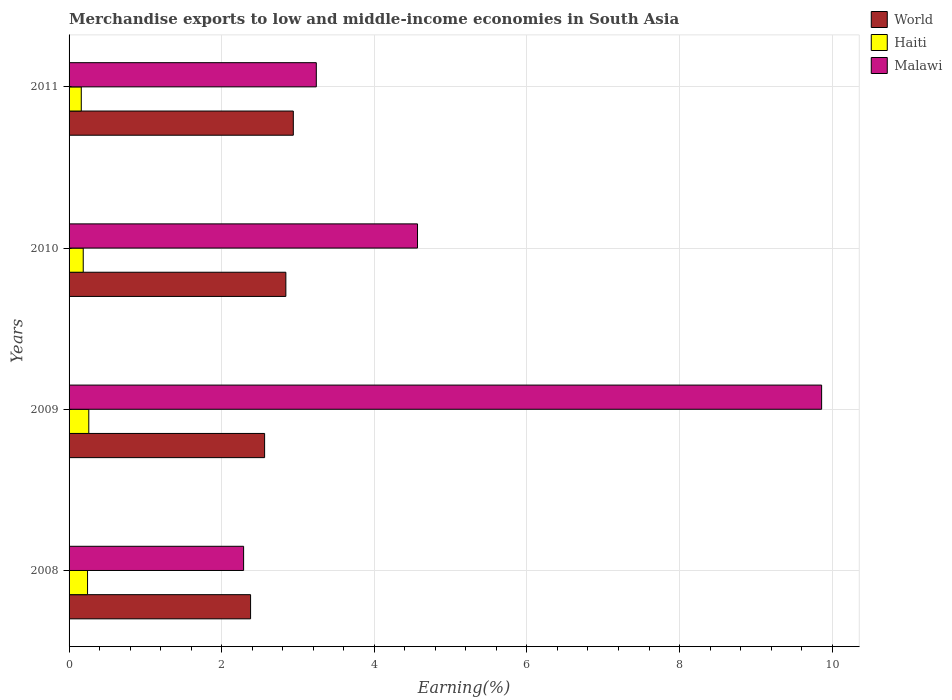How many groups of bars are there?
Offer a very short reply. 4. Are the number of bars per tick equal to the number of legend labels?
Keep it short and to the point. Yes. Are the number of bars on each tick of the Y-axis equal?
Your answer should be compact. Yes. How many bars are there on the 3rd tick from the top?
Offer a very short reply. 3. How many bars are there on the 2nd tick from the bottom?
Keep it short and to the point. 3. What is the label of the 2nd group of bars from the top?
Offer a very short reply. 2010. In how many cases, is the number of bars for a given year not equal to the number of legend labels?
Give a very brief answer. 0. What is the percentage of amount earned from merchandise exports in Haiti in 2008?
Offer a very short reply. 0.24. Across all years, what is the maximum percentage of amount earned from merchandise exports in Malawi?
Make the answer very short. 9.86. Across all years, what is the minimum percentage of amount earned from merchandise exports in World?
Ensure brevity in your answer.  2.38. In which year was the percentage of amount earned from merchandise exports in World maximum?
Your answer should be compact. 2011. What is the total percentage of amount earned from merchandise exports in Haiti in the graph?
Offer a terse response. 0.85. What is the difference between the percentage of amount earned from merchandise exports in World in 2010 and that in 2011?
Offer a very short reply. -0.1. What is the difference between the percentage of amount earned from merchandise exports in World in 2010 and the percentage of amount earned from merchandise exports in Haiti in 2008?
Make the answer very short. 2.6. What is the average percentage of amount earned from merchandise exports in World per year?
Keep it short and to the point. 2.68. In the year 2009, what is the difference between the percentage of amount earned from merchandise exports in Malawi and percentage of amount earned from merchandise exports in World?
Ensure brevity in your answer.  7.3. In how many years, is the percentage of amount earned from merchandise exports in Malawi greater than 3.2 %?
Your answer should be very brief. 3. What is the ratio of the percentage of amount earned from merchandise exports in Haiti in 2008 to that in 2010?
Your answer should be very brief. 1.3. Is the percentage of amount earned from merchandise exports in World in 2008 less than that in 2010?
Make the answer very short. Yes. What is the difference between the highest and the second highest percentage of amount earned from merchandise exports in World?
Your response must be concise. 0.1. What is the difference between the highest and the lowest percentage of amount earned from merchandise exports in World?
Give a very brief answer. 0.56. What does the 2nd bar from the top in 2011 represents?
Make the answer very short. Haiti. What does the 1st bar from the bottom in 2009 represents?
Keep it short and to the point. World. How many bars are there?
Provide a short and direct response. 12. What is the difference between two consecutive major ticks on the X-axis?
Your answer should be very brief. 2. Are the values on the major ticks of X-axis written in scientific E-notation?
Offer a terse response. No. Does the graph contain any zero values?
Your answer should be compact. No. How many legend labels are there?
Your answer should be very brief. 3. How are the legend labels stacked?
Ensure brevity in your answer.  Vertical. What is the title of the graph?
Provide a succinct answer. Merchandise exports to low and middle-income economies in South Asia. What is the label or title of the X-axis?
Give a very brief answer. Earning(%). What is the label or title of the Y-axis?
Your response must be concise. Years. What is the Earning(%) in World in 2008?
Provide a short and direct response. 2.38. What is the Earning(%) in Haiti in 2008?
Provide a succinct answer. 0.24. What is the Earning(%) in Malawi in 2008?
Make the answer very short. 2.29. What is the Earning(%) in World in 2009?
Offer a terse response. 2.56. What is the Earning(%) of Haiti in 2009?
Ensure brevity in your answer.  0.26. What is the Earning(%) of Malawi in 2009?
Keep it short and to the point. 9.86. What is the Earning(%) in World in 2010?
Ensure brevity in your answer.  2.84. What is the Earning(%) in Haiti in 2010?
Offer a very short reply. 0.19. What is the Earning(%) in Malawi in 2010?
Keep it short and to the point. 4.57. What is the Earning(%) in World in 2011?
Give a very brief answer. 2.94. What is the Earning(%) in Haiti in 2011?
Offer a terse response. 0.16. What is the Earning(%) in Malawi in 2011?
Provide a succinct answer. 3.24. Across all years, what is the maximum Earning(%) in World?
Ensure brevity in your answer.  2.94. Across all years, what is the maximum Earning(%) in Haiti?
Provide a succinct answer. 0.26. Across all years, what is the maximum Earning(%) in Malawi?
Your response must be concise. 9.86. Across all years, what is the minimum Earning(%) in World?
Your answer should be compact. 2.38. Across all years, what is the minimum Earning(%) in Haiti?
Offer a very short reply. 0.16. Across all years, what is the minimum Earning(%) of Malawi?
Keep it short and to the point. 2.29. What is the total Earning(%) in World in the graph?
Make the answer very short. 10.72. What is the total Earning(%) of Haiti in the graph?
Provide a short and direct response. 0.85. What is the total Earning(%) in Malawi in the graph?
Give a very brief answer. 19.96. What is the difference between the Earning(%) in World in 2008 and that in 2009?
Your answer should be compact. -0.18. What is the difference between the Earning(%) of Haiti in 2008 and that in 2009?
Offer a very short reply. -0.02. What is the difference between the Earning(%) of Malawi in 2008 and that in 2009?
Your response must be concise. -7.57. What is the difference between the Earning(%) in World in 2008 and that in 2010?
Provide a succinct answer. -0.46. What is the difference between the Earning(%) of Haiti in 2008 and that in 2010?
Offer a terse response. 0.06. What is the difference between the Earning(%) of Malawi in 2008 and that in 2010?
Make the answer very short. -2.28. What is the difference between the Earning(%) in World in 2008 and that in 2011?
Your answer should be compact. -0.56. What is the difference between the Earning(%) in Haiti in 2008 and that in 2011?
Offer a terse response. 0.08. What is the difference between the Earning(%) of Malawi in 2008 and that in 2011?
Give a very brief answer. -0.95. What is the difference between the Earning(%) of World in 2009 and that in 2010?
Give a very brief answer. -0.28. What is the difference between the Earning(%) in Haiti in 2009 and that in 2010?
Your response must be concise. 0.07. What is the difference between the Earning(%) of Malawi in 2009 and that in 2010?
Keep it short and to the point. 5.3. What is the difference between the Earning(%) in World in 2009 and that in 2011?
Ensure brevity in your answer.  -0.38. What is the difference between the Earning(%) in Haiti in 2009 and that in 2011?
Offer a terse response. 0.1. What is the difference between the Earning(%) of Malawi in 2009 and that in 2011?
Offer a terse response. 6.62. What is the difference between the Earning(%) of World in 2010 and that in 2011?
Ensure brevity in your answer.  -0.1. What is the difference between the Earning(%) of Haiti in 2010 and that in 2011?
Provide a short and direct response. 0.03. What is the difference between the Earning(%) of Malawi in 2010 and that in 2011?
Your response must be concise. 1.33. What is the difference between the Earning(%) of World in 2008 and the Earning(%) of Haiti in 2009?
Offer a terse response. 2.12. What is the difference between the Earning(%) of World in 2008 and the Earning(%) of Malawi in 2009?
Give a very brief answer. -7.48. What is the difference between the Earning(%) in Haiti in 2008 and the Earning(%) in Malawi in 2009?
Provide a succinct answer. -9.62. What is the difference between the Earning(%) of World in 2008 and the Earning(%) of Haiti in 2010?
Give a very brief answer. 2.19. What is the difference between the Earning(%) of World in 2008 and the Earning(%) of Malawi in 2010?
Give a very brief answer. -2.19. What is the difference between the Earning(%) in Haiti in 2008 and the Earning(%) in Malawi in 2010?
Offer a terse response. -4.32. What is the difference between the Earning(%) in World in 2008 and the Earning(%) in Haiti in 2011?
Your response must be concise. 2.22. What is the difference between the Earning(%) of World in 2008 and the Earning(%) of Malawi in 2011?
Offer a very short reply. -0.86. What is the difference between the Earning(%) in Haiti in 2008 and the Earning(%) in Malawi in 2011?
Give a very brief answer. -3. What is the difference between the Earning(%) of World in 2009 and the Earning(%) of Haiti in 2010?
Your answer should be very brief. 2.38. What is the difference between the Earning(%) of World in 2009 and the Earning(%) of Malawi in 2010?
Provide a short and direct response. -2. What is the difference between the Earning(%) of Haiti in 2009 and the Earning(%) of Malawi in 2010?
Give a very brief answer. -4.31. What is the difference between the Earning(%) in World in 2009 and the Earning(%) in Haiti in 2011?
Your response must be concise. 2.4. What is the difference between the Earning(%) of World in 2009 and the Earning(%) of Malawi in 2011?
Your response must be concise. -0.68. What is the difference between the Earning(%) of Haiti in 2009 and the Earning(%) of Malawi in 2011?
Your answer should be very brief. -2.98. What is the difference between the Earning(%) in World in 2010 and the Earning(%) in Haiti in 2011?
Keep it short and to the point. 2.68. What is the difference between the Earning(%) in World in 2010 and the Earning(%) in Malawi in 2011?
Offer a very short reply. -0.4. What is the difference between the Earning(%) of Haiti in 2010 and the Earning(%) of Malawi in 2011?
Provide a succinct answer. -3.05. What is the average Earning(%) in World per year?
Your answer should be compact. 2.68. What is the average Earning(%) of Haiti per year?
Keep it short and to the point. 0.21. What is the average Earning(%) in Malawi per year?
Your answer should be compact. 4.99. In the year 2008, what is the difference between the Earning(%) of World and Earning(%) of Haiti?
Your response must be concise. 2.14. In the year 2008, what is the difference between the Earning(%) of World and Earning(%) of Malawi?
Your answer should be compact. 0.09. In the year 2008, what is the difference between the Earning(%) in Haiti and Earning(%) in Malawi?
Make the answer very short. -2.05. In the year 2009, what is the difference between the Earning(%) of World and Earning(%) of Haiti?
Provide a succinct answer. 2.3. In the year 2009, what is the difference between the Earning(%) in World and Earning(%) in Malawi?
Offer a very short reply. -7.3. In the year 2009, what is the difference between the Earning(%) of Haiti and Earning(%) of Malawi?
Give a very brief answer. -9.6. In the year 2010, what is the difference between the Earning(%) of World and Earning(%) of Haiti?
Give a very brief answer. 2.66. In the year 2010, what is the difference between the Earning(%) in World and Earning(%) in Malawi?
Your answer should be compact. -1.73. In the year 2010, what is the difference between the Earning(%) in Haiti and Earning(%) in Malawi?
Offer a very short reply. -4.38. In the year 2011, what is the difference between the Earning(%) in World and Earning(%) in Haiti?
Provide a short and direct response. 2.78. In the year 2011, what is the difference between the Earning(%) of World and Earning(%) of Malawi?
Give a very brief answer. -0.3. In the year 2011, what is the difference between the Earning(%) of Haiti and Earning(%) of Malawi?
Keep it short and to the point. -3.08. What is the ratio of the Earning(%) of World in 2008 to that in 2009?
Your answer should be compact. 0.93. What is the ratio of the Earning(%) in Haiti in 2008 to that in 2009?
Ensure brevity in your answer.  0.94. What is the ratio of the Earning(%) of Malawi in 2008 to that in 2009?
Offer a very short reply. 0.23. What is the ratio of the Earning(%) in World in 2008 to that in 2010?
Offer a very short reply. 0.84. What is the ratio of the Earning(%) of Haiti in 2008 to that in 2010?
Offer a terse response. 1.3. What is the ratio of the Earning(%) in Malawi in 2008 to that in 2010?
Keep it short and to the point. 0.5. What is the ratio of the Earning(%) of World in 2008 to that in 2011?
Ensure brevity in your answer.  0.81. What is the ratio of the Earning(%) in Haiti in 2008 to that in 2011?
Ensure brevity in your answer.  1.51. What is the ratio of the Earning(%) in Malawi in 2008 to that in 2011?
Give a very brief answer. 0.71. What is the ratio of the Earning(%) of World in 2009 to that in 2010?
Provide a succinct answer. 0.9. What is the ratio of the Earning(%) of Haiti in 2009 to that in 2010?
Provide a succinct answer. 1.39. What is the ratio of the Earning(%) in Malawi in 2009 to that in 2010?
Provide a short and direct response. 2.16. What is the ratio of the Earning(%) of World in 2009 to that in 2011?
Offer a terse response. 0.87. What is the ratio of the Earning(%) of Haiti in 2009 to that in 2011?
Offer a terse response. 1.62. What is the ratio of the Earning(%) of Malawi in 2009 to that in 2011?
Keep it short and to the point. 3.04. What is the ratio of the Earning(%) of World in 2010 to that in 2011?
Give a very brief answer. 0.97. What is the ratio of the Earning(%) of Haiti in 2010 to that in 2011?
Offer a very short reply. 1.16. What is the ratio of the Earning(%) in Malawi in 2010 to that in 2011?
Make the answer very short. 1.41. What is the difference between the highest and the second highest Earning(%) of World?
Give a very brief answer. 0.1. What is the difference between the highest and the second highest Earning(%) of Haiti?
Provide a succinct answer. 0.02. What is the difference between the highest and the second highest Earning(%) of Malawi?
Ensure brevity in your answer.  5.3. What is the difference between the highest and the lowest Earning(%) in World?
Offer a very short reply. 0.56. What is the difference between the highest and the lowest Earning(%) in Haiti?
Ensure brevity in your answer.  0.1. What is the difference between the highest and the lowest Earning(%) of Malawi?
Ensure brevity in your answer.  7.57. 